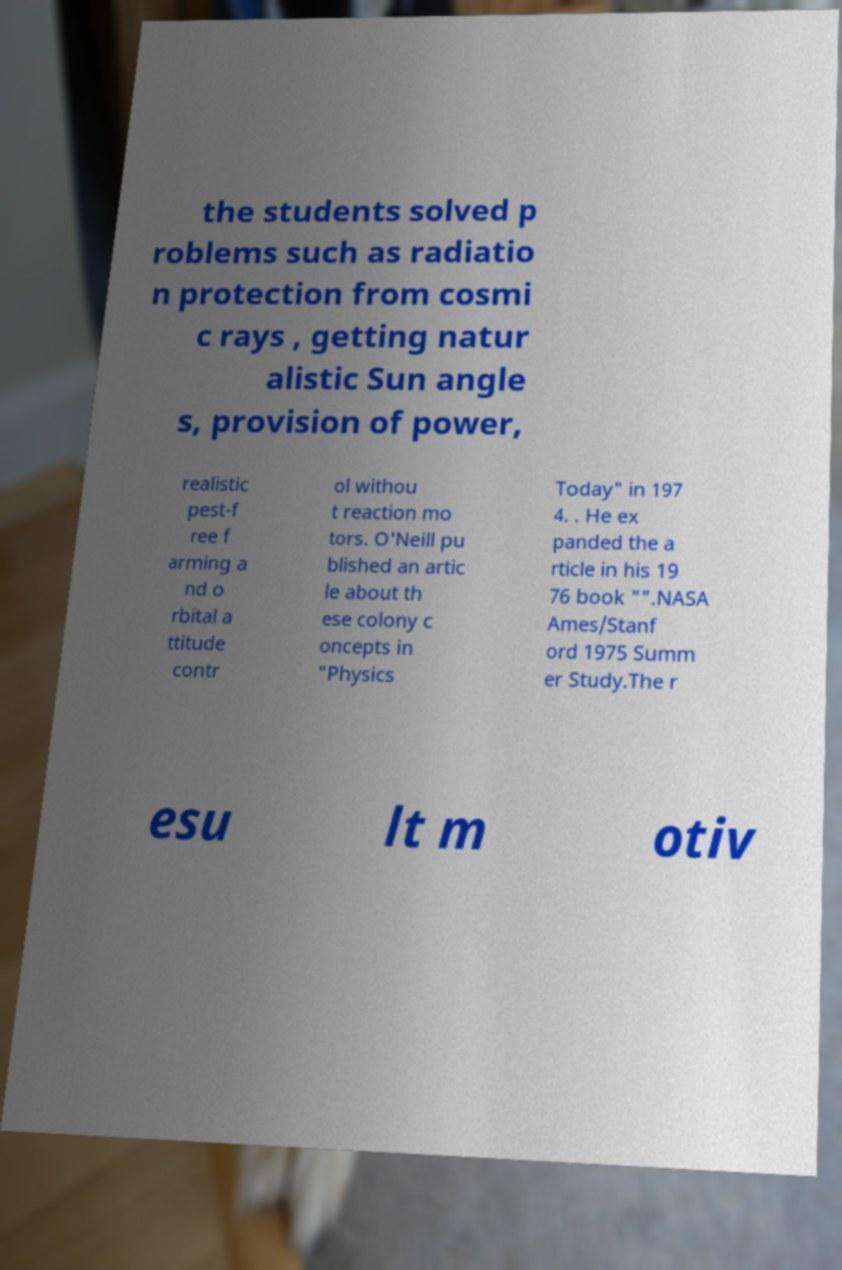I need the written content from this picture converted into text. Can you do that? the students solved p roblems such as radiatio n protection from cosmi c rays , getting natur alistic Sun angle s, provision of power, realistic pest-f ree f arming a nd o rbital a ttitude contr ol withou t reaction mo tors. O'Neill pu blished an artic le about th ese colony c oncepts in "Physics Today" in 197 4. . He ex panded the a rticle in his 19 76 book "".NASA Ames/Stanf ord 1975 Summ er Study.The r esu lt m otiv 